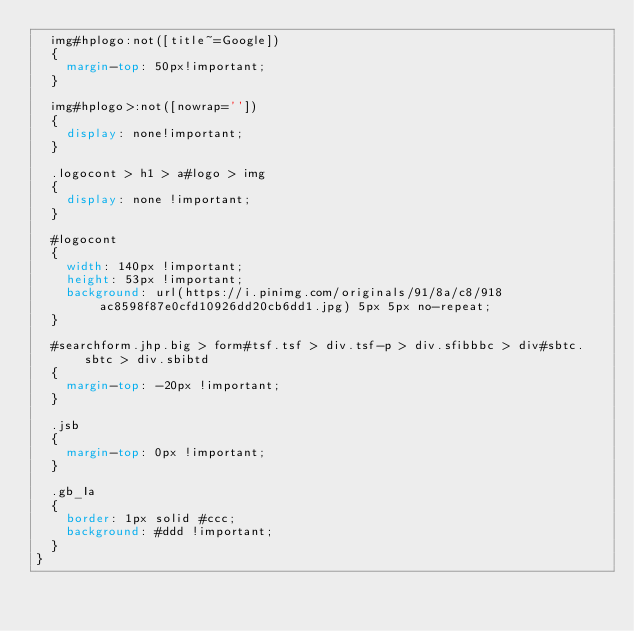Convert code to text. <code><loc_0><loc_0><loc_500><loc_500><_CSS_>  img#hplogo:not([title~=Google])
  {
    margin-top: 50px!important;
  }

  img#hplogo>:not([nowrap=''])
  {
    display: none!important;
  }

  .logocont > h1 > a#logo > img
  {
    display: none !important;
  }

  #logocont
  {
    width: 140px !important;
    height: 53px !important;
    background: url(https://i.pinimg.com/originals/91/8a/c8/918ac8598f87e0cfd10926dd20cb6dd1.jpg) 5px 5px no-repeat;
  }

  #searchform.jhp.big > form#tsf.tsf > div.tsf-p > div.sfibbbc > div#sbtc.sbtc > div.sbibtd
  {
    margin-top: -20px !important;
  }

  .jsb
  {
    margin-top: 0px !important;
  }

  .gb_Ia
  {
    border: 1px solid #ccc;
    background: #ddd !important;
  }
}
</code> 